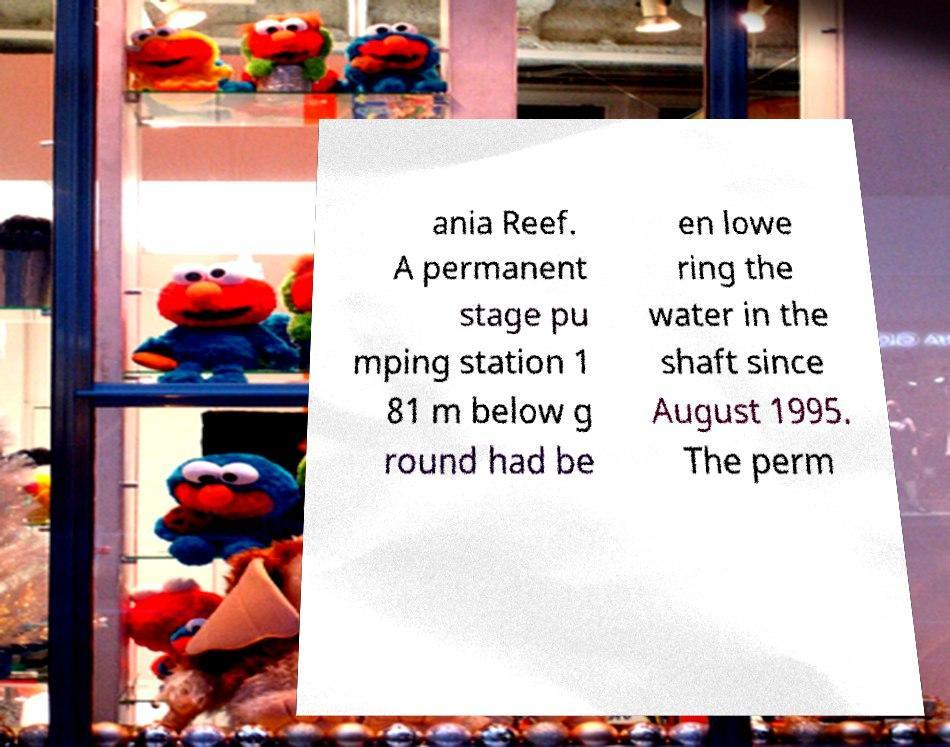I need the written content from this picture converted into text. Can you do that? ania Reef. A permanent stage pu mping station 1 81 m below g round had be en lowe ring the water in the shaft since August 1995. The perm 